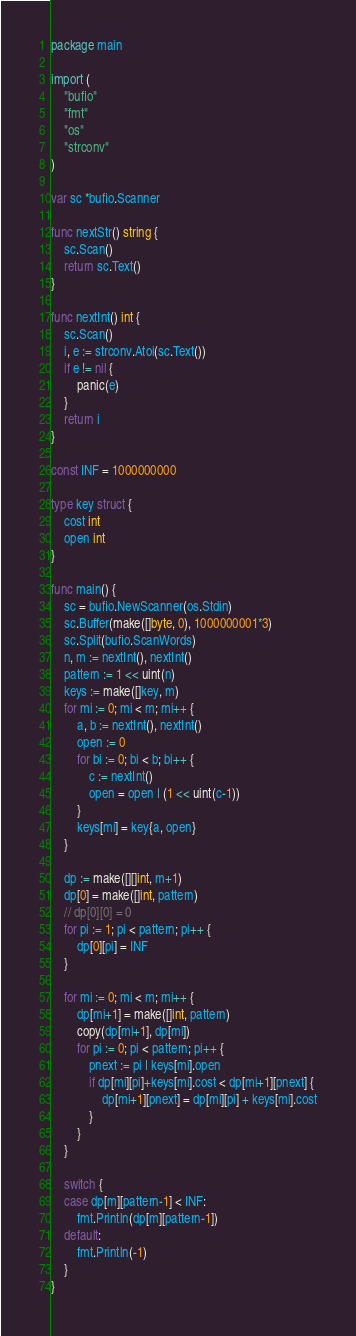<code> <loc_0><loc_0><loc_500><loc_500><_Go_>package main

import (
	"bufio"
	"fmt"
	"os"
	"strconv"
)

var sc *bufio.Scanner

func nextStr() string {
	sc.Scan()
	return sc.Text()
}

func nextInt() int {
	sc.Scan()
	i, e := strconv.Atoi(sc.Text())
	if e != nil {
		panic(e)
	}
	return i
}

const INF = 1000000000

type key struct {
	cost int
	open int
}

func main() {
	sc = bufio.NewScanner(os.Stdin)
	sc.Buffer(make([]byte, 0), 1000000001*3)
	sc.Split(bufio.ScanWords)
	n, m := nextInt(), nextInt()
	pattern := 1 << uint(n)
	keys := make([]key, m)
	for mi := 0; mi < m; mi++ {
		a, b := nextInt(), nextInt()
		open := 0
		for bi := 0; bi < b; bi++ {
			c := nextInt()
			open = open | (1 << uint(c-1))
		}
		keys[mi] = key{a, open}
	}

	dp := make([][]int, m+1)
	dp[0] = make([]int, pattern)
	// dp[0][0] = 0
	for pi := 1; pi < pattern; pi++ {
		dp[0][pi] = INF
	}

	for mi := 0; mi < m; mi++ {
		dp[mi+1] = make([]int, pattern)
		copy(dp[mi+1], dp[mi])
		for pi := 0; pi < pattern; pi++ {
			pnext := pi | keys[mi].open
			if dp[mi][pi]+keys[mi].cost < dp[mi+1][pnext] {
				dp[mi+1][pnext] = dp[mi][pi] + keys[mi].cost
			}
		}
	}

	switch {
	case dp[m][pattern-1] < INF:
		fmt.Println(dp[m][pattern-1])
	default:
		fmt.Println(-1)
	}
}
</code> 